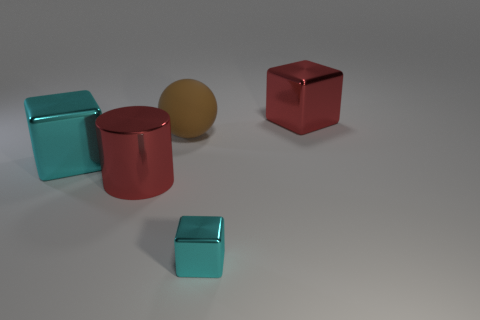Add 1 big green matte blocks. How many objects exist? 6 Subtract all balls. How many objects are left? 4 Add 4 large red cubes. How many large red cubes are left? 5 Add 2 yellow metal cubes. How many yellow metal cubes exist? 2 Subtract 0 gray spheres. How many objects are left? 5 Subtract all red metallic things. Subtract all shiny cylinders. How many objects are left? 2 